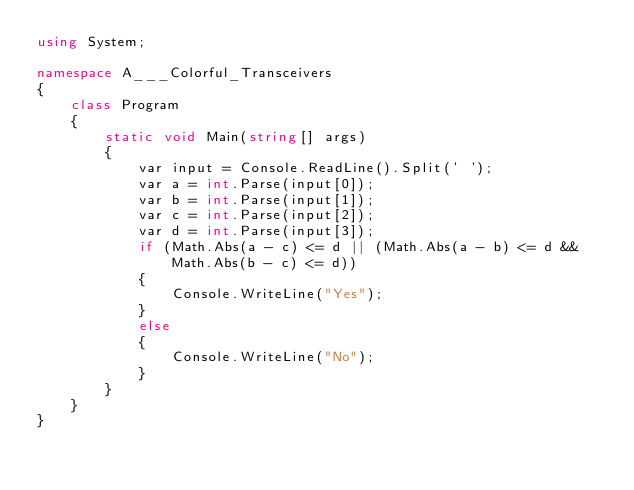<code> <loc_0><loc_0><loc_500><loc_500><_C#_>using System;

namespace A___Colorful_Transceivers
{
    class Program
    {
        static void Main(string[] args)
        {
            var input = Console.ReadLine().Split(' ');
            var a = int.Parse(input[0]);
            var b = int.Parse(input[1]);
            var c = int.Parse(input[2]);
            var d = int.Parse(input[3]);
            if (Math.Abs(a - c) <= d || (Math.Abs(a - b) <= d && Math.Abs(b - c) <= d))
            {
                Console.WriteLine("Yes");
            }
            else
            {
                Console.WriteLine("No");
            }
        }
    }
}</code> 